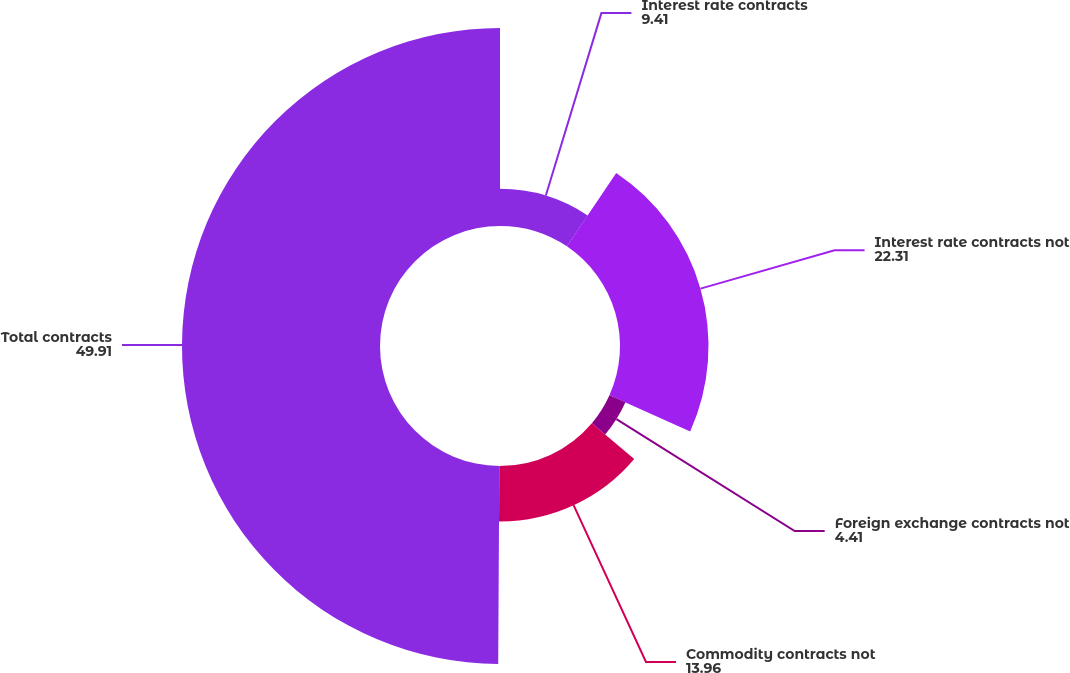Convert chart. <chart><loc_0><loc_0><loc_500><loc_500><pie_chart><fcel>Interest rate contracts<fcel>Interest rate contracts not<fcel>Foreign exchange contracts not<fcel>Commodity contracts not<fcel>Total contracts<nl><fcel>9.41%<fcel>22.31%<fcel>4.41%<fcel>13.96%<fcel>49.91%<nl></chart> 